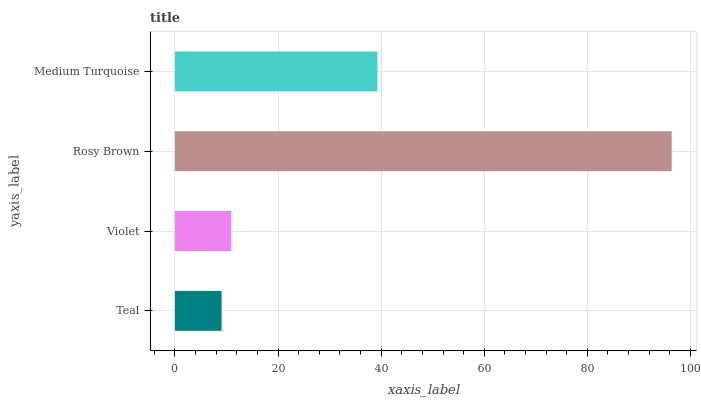Is Teal the minimum?
Answer yes or no. Yes. Is Rosy Brown the maximum?
Answer yes or no. Yes. Is Violet the minimum?
Answer yes or no. No. Is Violet the maximum?
Answer yes or no. No. Is Violet greater than Teal?
Answer yes or no. Yes. Is Teal less than Violet?
Answer yes or no. Yes. Is Teal greater than Violet?
Answer yes or no. No. Is Violet less than Teal?
Answer yes or no. No. Is Medium Turquoise the high median?
Answer yes or no. Yes. Is Violet the low median?
Answer yes or no. Yes. Is Teal the high median?
Answer yes or no. No. Is Medium Turquoise the low median?
Answer yes or no. No. 